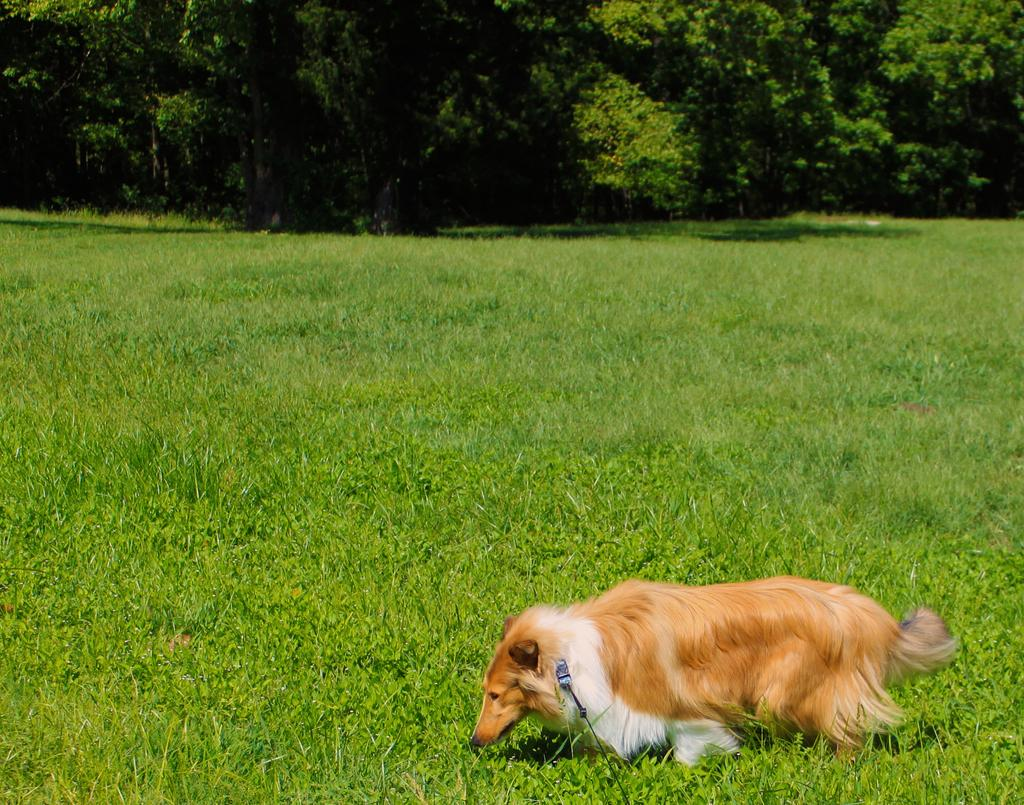What type of animal is in the picture? The type of animal cannot be determined from the provided facts. What is the color of the grass in the picture? The grass in the picture is green. What other natural elements are present in the picture? There are trees in the picture. What type of cake is being served on the beach in the picture? There is no cake or beach present in the picture; it only mentions an animal, green grass, and trees. 